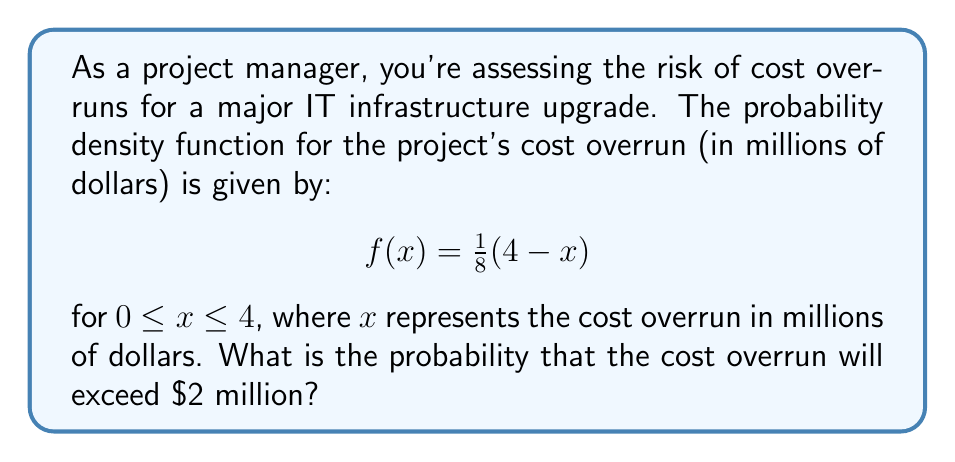Give your solution to this math problem. To solve this problem, we need to integrate the probability density function from 2 to 4, as we're interested in the probability of the cost overrun exceeding $2 million.

1) The probability is given by the integral:

   $$P(X > 2) = \int_2^4 f(x) dx = \int_2^4 \frac{1}{8}(4-x) dx$$

2) Let's solve this integral step by step:

   $$\int_2^4 \frac{1}{8}(4-x) dx = \frac{1}{8} \int_2^4 (4-x) dx$$

3) Integrate:

   $$\frac{1}{8} \left[4x - \frac{x^2}{2}\right]_2^4$$

4) Evaluate the integral at the limits:

   $$\frac{1}{8} \left[(4(4) - \frac{4^2}{2}) - (4(2) - \frac{2^2}{2})\right]$$

5) Simplify:

   $$\frac{1}{8} \left[(16 - 8) - (8 - 2)\right] = \frac{1}{8} [8 - 6] = \frac{1}{8} \cdot 2 = \frac{1}{4}$$

Therefore, the probability that the cost overrun will exceed $2 million is $\frac{1}{4}$ or 0.25 or 25%.
Answer: $\frac{1}{4}$ or 0.25 or 25% 